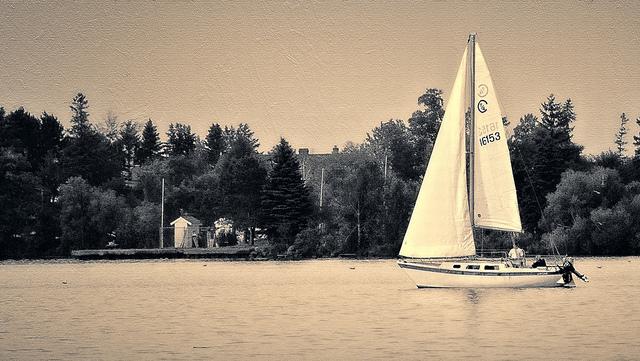What is written on the sail?
Be succinct. Numbers. What it the sailboat in front of?
Be succinct. Trees. Is this an old photo?
Keep it brief. Yes. How big is the boat?
Short answer required. Small. 